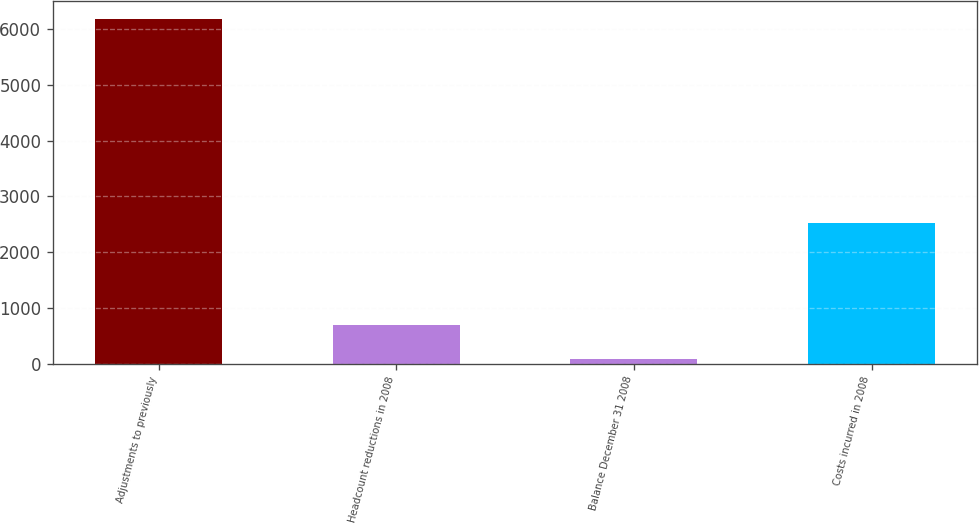Convert chart. <chart><loc_0><loc_0><loc_500><loc_500><bar_chart><fcel>Adjustments to previously<fcel>Headcount reductions in 2008<fcel>Balance December 31 2008<fcel>Costs incurred in 2008<nl><fcel>6193<fcel>695.8<fcel>85<fcel>2518<nl></chart> 